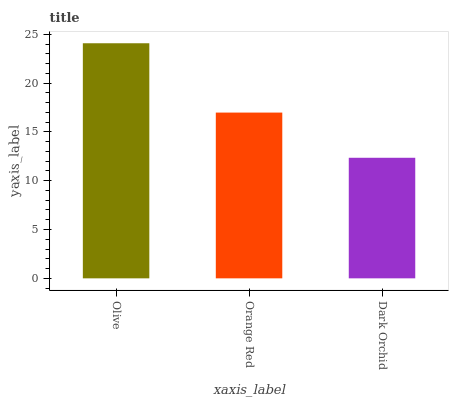Is Dark Orchid the minimum?
Answer yes or no. Yes. Is Olive the maximum?
Answer yes or no. Yes. Is Orange Red the minimum?
Answer yes or no. No. Is Orange Red the maximum?
Answer yes or no. No. Is Olive greater than Orange Red?
Answer yes or no. Yes. Is Orange Red less than Olive?
Answer yes or no. Yes. Is Orange Red greater than Olive?
Answer yes or no. No. Is Olive less than Orange Red?
Answer yes or no. No. Is Orange Red the high median?
Answer yes or no. Yes. Is Orange Red the low median?
Answer yes or no. Yes. Is Olive the high median?
Answer yes or no. No. Is Olive the low median?
Answer yes or no. No. 